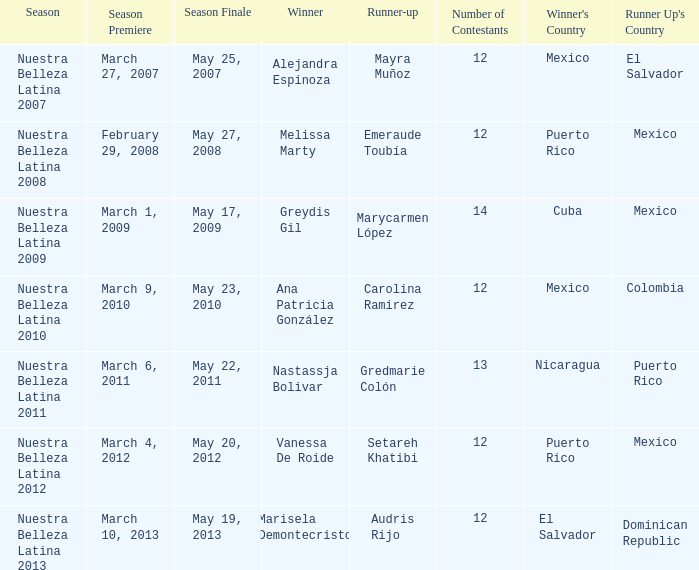During which season was mexico the runner-up while melissa marty claimed victory? Nuestra Belleza Latina 2008. 